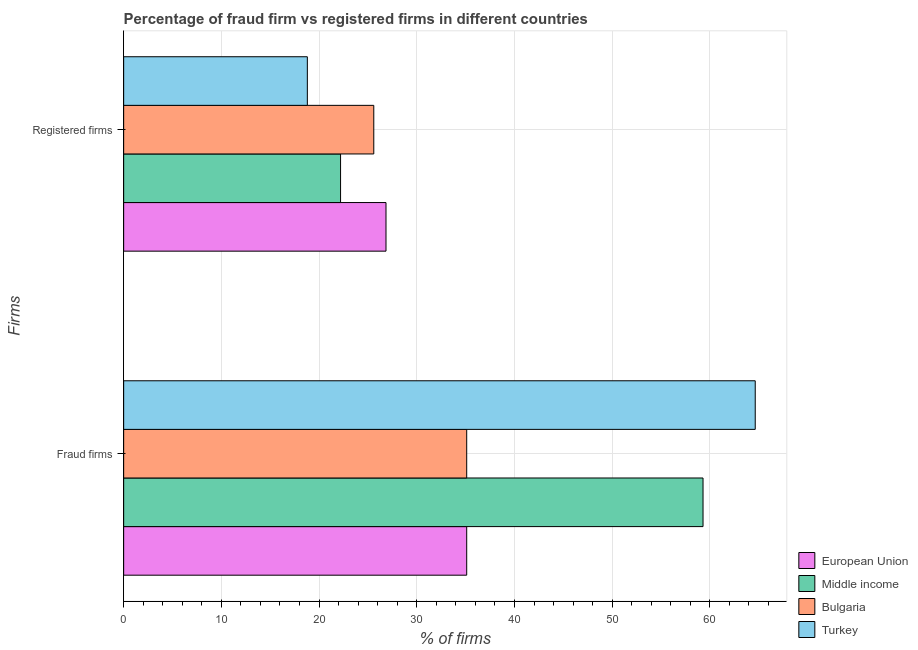How many groups of bars are there?
Your answer should be very brief. 2. Are the number of bars on each tick of the Y-axis equal?
Offer a terse response. Yes. How many bars are there on the 2nd tick from the top?
Ensure brevity in your answer.  4. What is the label of the 1st group of bars from the top?
Offer a very short reply. Registered firms. Across all countries, what is the maximum percentage of fraud firms?
Ensure brevity in your answer.  64.64. Across all countries, what is the minimum percentage of fraud firms?
Your answer should be compact. 35.11. In which country was the percentage of registered firms maximum?
Provide a short and direct response. European Union. What is the total percentage of registered firms in the graph?
Make the answer very short. 93.45. What is the difference between the percentage of fraud firms in Turkey and that in European Union?
Provide a short and direct response. 29.53. What is the difference between the percentage of registered firms in Middle income and the percentage of fraud firms in Turkey?
Your response must be concise. -42.44. What is the average percentage of registered firms per country?
Ensure brevity in your answer.  23.36. What is the difference between the percentage of registered firms and percentage of fraud firms in Turkey?
Your response must be concise. -45.84. In how many countries, is the percentage of registered firms greater than 26 %?
Keep it short and to the point. 1. What is the ratio of the percentage of registered firms in European Union to that in Bulgaria?
Ensure brevity in your answer.  1.05. In how many countries, is the percentage of registered firms greater than the average percentage of registered firms taken over all countries?
Your response must be concise. 2. What does the 3rd bar from the bottom in Registered firms represents?
Make the answer very short. Bulgaria. What is the difference between two consecutive major ticks on the X-axis?
Offer a terse response. 10. Does the graph contain any zero values?
Offer a very short reply. No. Where does the legend appear in the graph?
Make the answer very short. Bottom right. How many legend labels are there?
Provide a succinct answer. 4. What is the title of the graph?
Keep it short and to the point. Percentage of fraud firm vs registered firms in different countries. Does "Japan" appear as one of the legend labels in the graph?
Your answer should be compact. No. What is the label or title of the X-axis?
Keep it short and to the point. % of firms. What is the label or title of the Y-axis?
Offer a terse response. Firms. What is the % of firms of European Union in Fraud firms?
Keep it short and to the point. 35.11. What is the % of firms of Middle income in Fraud firms?
Your answer should be compact. 59.3. What is the % of firms in Bulgaria in Fraud firms?
Your answer should be compact. 35.11. What is the % of firms in Turkey in Fraud firms?
Keep it short and to the point. 64.64. What is the % of firms of European Union in Registered firms?
Your response must be concise. 26.85. What is the % of firms of Middle income in Registered firms?
Offer a very short reply. 22.2. What is the % of firms in Bulgaria in Registered firms?
Keep it short and to the point. 25.6. Across all Firms, what is the maximum % of firms in European Union?
Offer a terse response. 35.11. Across all Firms, what is the maximum % of firms in Middle income?
Your answer should be compact. 59.3. Across all Firms, what is the maximum % of firms in Bulgaria?
Make the answer very short. 35.11. Across all Firms, what is the maximum % of firms in Turkey?
Your answer should be very brief. 64.64. Across all Firms, what is the minimum % of firms in European Union?
Make the answer very short. 26.85. Across all Firms, what is the minimum % of firms in Middle income?
Offer a terse response. 22.2. Across all Firms, what is the minimum % of firms in Bulgaria?
Ensure brevity in your answer.  25.6. Across all Firms, what is the minimum % of firms of Turkey?
Make the answer very short. 18.8. What is the total % of firms of European Union in the graph?
Keep it short and to the point. 61.96. What is the total % of firms of Middle income in the graph?
Offer a very short reply. 81.5. What is the total % of firms of Bulgaria in the graph?
Provide a short and direct response. 60.71. What is the total % of firms of Turkey in the graph?
Make the answer very short. 83.44. What is the difference between the % of firms of European Union in Fraud firms and that in Registered firms?
Ensure brevity in your answer.  8.26. What is the difference between the % of firms in Middle income in Fraud firms and that in Registered firms?
Make the answer very short. 37.1. What is the difference between the % of firms in Bulgaria in Fraud firms and that in Registered firms?
Provide a short and direct response. 9.51. What is the difference between the % of firms in Turkey in Fraud firms and that in Registered firms?
Offer a very short reply. 45.84. What is the difference between the % of firms of European Union in Fraud firms and the % of firms of Middle income in Registered firms?
Provide a succinct answer. 12.91. What is the difference between the % of firms in European Union in Fraud firms and the % of firms in Bulgaria in Registered firms?
Provide a succinct answer. 9.51. What is the difference between the % of firms of European Union in Fraud firms and the % of firms of Turkey in Registered firms?
Offer a terse response. 16.31. What is the difference between the % of firms in Middle income in Fraud firms and the % of firms in Bulgaria in Registered firms?
Your answer should be compact. 33.7. What is the difference between the % of firms in Middle income in Fraud firms and the % of firms in Turkey in Registered firms?
Offer a very short reply. 40.5. What is the difference between the % of firms of Bulgaria in Fraud firms and the % of firms of Turkey in Registered firms?
Make the answer very short. 16.31. What is the average % of firms in European Union per Firms?
Offer a very short reply. 30.98. What is the average % of firms in Middle income per Firms?
Give a very brief answer. 40.75. What is the average % of firms of Bulgaria per Firms?
Keep it short and to the point. 30.36. What is the average % of firms of Turkey per Firms?
Give a very brief answer. 41.72. What is the difference between the % of firms of European Union and % of firms of Middle income in Fraud firms?
Your answer should be compact. -24.19. What is the difference between the % of firms of European Union and % of firms of Bulgaria in Fraud firms?
Your response must be concise. 0. What is the difference between the % of firms of European Union and % of firms of Turkey in Fraud firms?
Make the answer very short. -29.53. What is the difference between the % of firms in Middle income and % of firms in Bulgaria in Fraud firms?
Your answer should be very brief. 24.19. What is the difference between the % of firms in Middle income and % of firms in Turkey in Fraud firms?
Your answer should be compact. -5.34. What is the difference between the % of firms in Bulgaria and % of firms in Turkey in Fraud firms?
Offer a very short reply. -29.53. What is the difference between the % of firms in European Union and % of firms in Middle income in Registered firms?
Your answer should be compact. 4.65. What is the difference between the % of firms of European Union and % of firms of Turkey in Registered firms?
Make the answer very short. 8.05. What is the difference between the % of firms in Middle income and % of firms in Bulgaria in Registered firms?
Give a very brief answer. -3.4. What is the difference between the % of firms in Bulgaria and % of firms in Turkey in Registered firms?
Offer a very short reply. 6.8. What is the ratio of the % of firms of European Union in Fraud firms to that in Registered firms?
Offer a terse response. 1.31. What is the ratio of the % of firms in Middle income in Fraud firms to that in Registered firms?
Make the answer very short. 2.67. What is the ratio of the % of firms in Bulgaria in Fraud firms to that in Registered firms?
Your answer should be very brief. 1.37. What is the ratio of the % of firms in Turkey in Fraud firms to that in Registered firms?
Ensure brevity in your answer.  3.44. What is the difference between the highest and the second highest % of firms of European Union?
Make the answer very short. 8.26. What is the difference between the highest and the second highest % of firms of Middle income?
Ensure brevity in your answer.  37.1. What is the difference between the highest and the second highest % of firms of Bulgaria?
Keep it short and to the point. 9.51. What is the difference between the highest and the second highest % of firms in Turkey?
Offer a terse response. 45.84. What is the difference between the highest and the lowest % of firms of European Union?
Provide a short and direct response. 8.26. What is the difference between the highest and the lowest % of firms of Middle income?
Your answer should be very brief. 37.1. What is the difference between the highest and the lowest % of firms of Bulgaria?
Offer a very short reply. 9.51. What is the difference between the highest and the lowest % of firms in Turkey?
Keep it short and to the point. 45.84. 